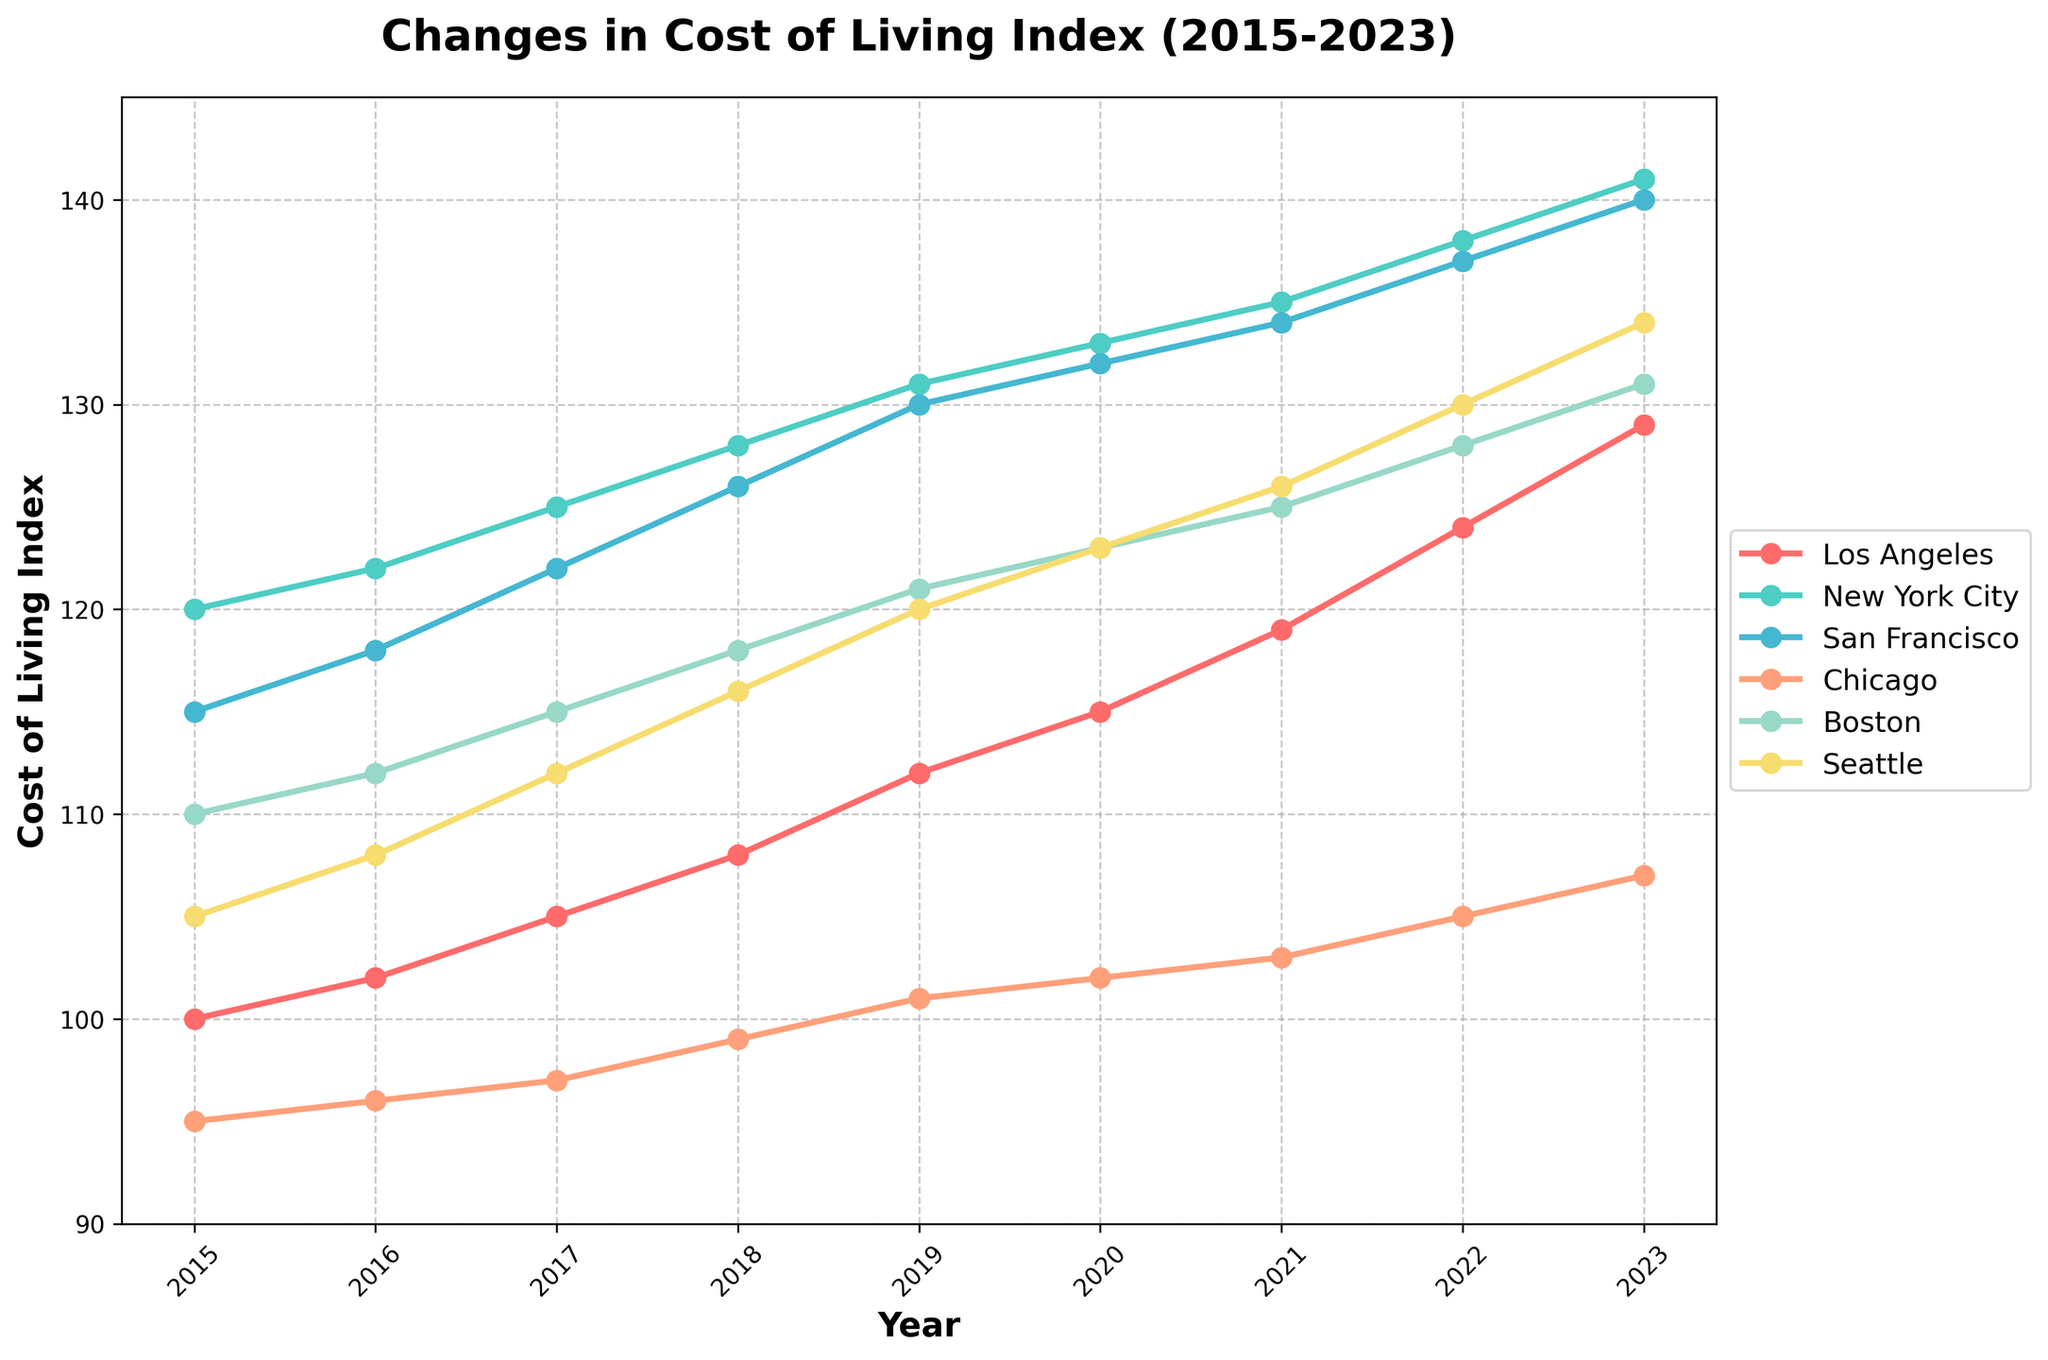Which city had the highest cost of living index in 2023? First, identify the cost of living index values for 2023. The values are: Los Angeles (129), New York City (141), San Francisco (140), Chicago (107), Boston (131), Seattle (134). New York City has the highest index value.
Answer: New York City How did the cost of living index for Los Angeles change from 2015 to 2023? Look at the cost of living index for Los Angeles in 2015 and 2023: 100 in 2015 and 129 in 2023. The change is 129 - 100 = 29.
Answer: Increased by 29 Which city had the smallest increase in cost of living index from 2015 to 2023? Calculate the increase for each city: Los Angeles (129-100=29), New York City (141-120=21), San Francisco (140-115=25), Chicago (107-95=12), Boston (131-110=21), Seattle (134-105=29). Chicago has the smallest increase.
Answer: Chicago What was the average cost of living index across all cities in 2020? Find the index values for 2020: Los Angeles (115), New York City (133), San Francisco (132), Chicago (102), Boston (123), Seattle (123). Sum these values (115 + 133 + 132 + 102 + 123 + 123) = 728. Now, divide by 6 (728 / 6) = 121.33.
Answer: 121.33 Between which consecutive years did Seattle see the largest increase in cost of living index? Calculate the year-to-year differences for Seattle: 2015-2016 (108-105=3), 2016-2017 (112-108=4), 2017-2018 (116-112=4), 2018-2019 (120-116=4), 2019-2020 (123-120=3), 2020-2021 (126-123=3), 2021-2022 (130-126=4), 2022-2023 (134-130=4). The largest increase is from 2016 to 2017, 2017 to 2018, 2018 to 2019, and 2021 to 2022, each with an increase of 4 points.
Answer: 2016 to 2017, 2017 to 2018, 2018 to 2019, 2021 to 2022 Which city's cost of living index remained closest to Los Angeles’s over the 2015-2023 period? Compare the year-to-year values of each city with Los Angeles and look for the smallest absolute differences. Seattle and Los Angeles have values close to each other over multiple years.
Answer: Seattle Was any city's cost of living index lower than Los Angeles's at any point in the given period? From the data, Chicago's index was consistently lower than Los Angeles's from 2015 to 2023. Compare the values to confirm.
Answer: Yes, Chicago What is the overall trend in the cost of living index for all the cities from 2015 to 2023? Observing the lines for each city, we see that all the lines show an upward trend, indicating an increase in the cost of living index over the period.
Answer: Increased By how many points did the cost of living index for New York City increase from 2015 to 2023? Calculate the difference between the 2023 and 2015 values for New York City. 141 - 120 = 21.
Answer: 21 